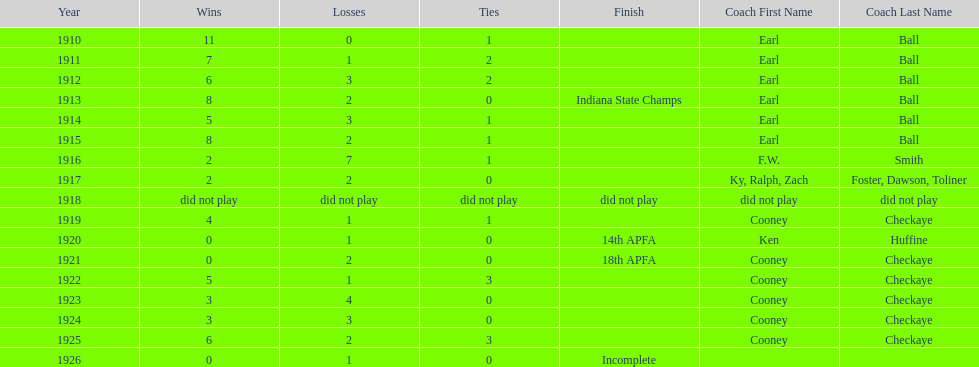How many years did cooney checkaye coach the muncie flyers? 6. 